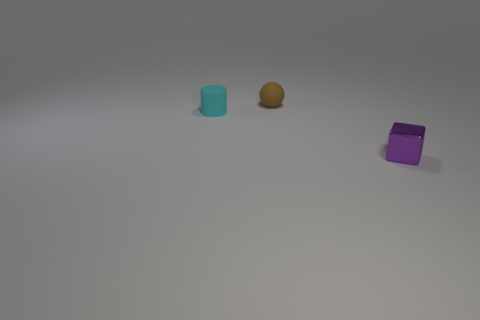There is a object to the right of the small brown ball; does it have the same color as the rubber ball?
Your response must be concise. No. Is there any other thing that has the same color as the small cube?
Ensure brevity in your answer.  No. The object on the right side of the rubber object right of the tiny matte object that is in front of the tiny brown sphere is what color?
Keep it short and to the point. Purple. Does the brown matte object have the same size as the purple shiny block?
Keep it short and to the point. Yes. What number of other balls are the same size as the rubber sphere?
Your answer should be very brief. 0. Are the object that is on the right side of the brown matte sphere and the thing left of the tiny brown object made of the same material?
Offer a very short reply. No. Is there anything else that is the same shape as the purple shiny thing?
Keep it short and to the point. No. What is the color of the tiny block?
Give a very brief answer. Purple. What number of other tiny brown objects have the same shape as the small brown rubber thing?
Your answer should be compact. 0. There is a shiny block that is the same size as the rubber ball; what color is it?
Your answer should be very brief. Purple. 